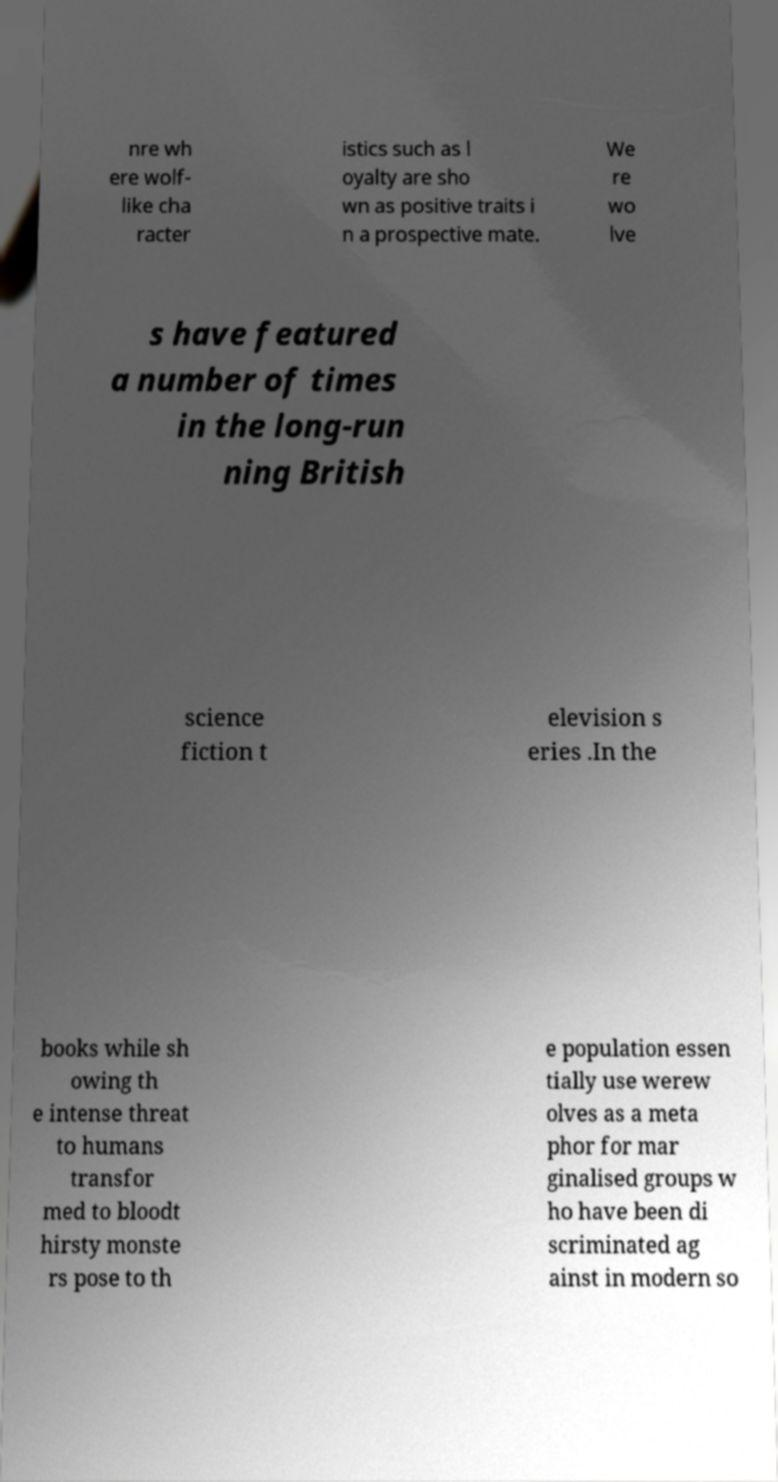Could you assist in decoding the text presented in this image and type it out clearly? nre wh ere wolf- like cha racter istics such as l oyalty are sho wn as positive traits i n a prospective mate. We re wo lve s have featured a number of times in the long-run ning British science fiction t elevision s eries .In the books while sh owing th e intense threat to humans transfor med to bloodt hirsty monste rs pose to th e population essen tially use werew olves as a meta phor for mar ginalised groups w ho have been di scriminated ag ainst in modern so 